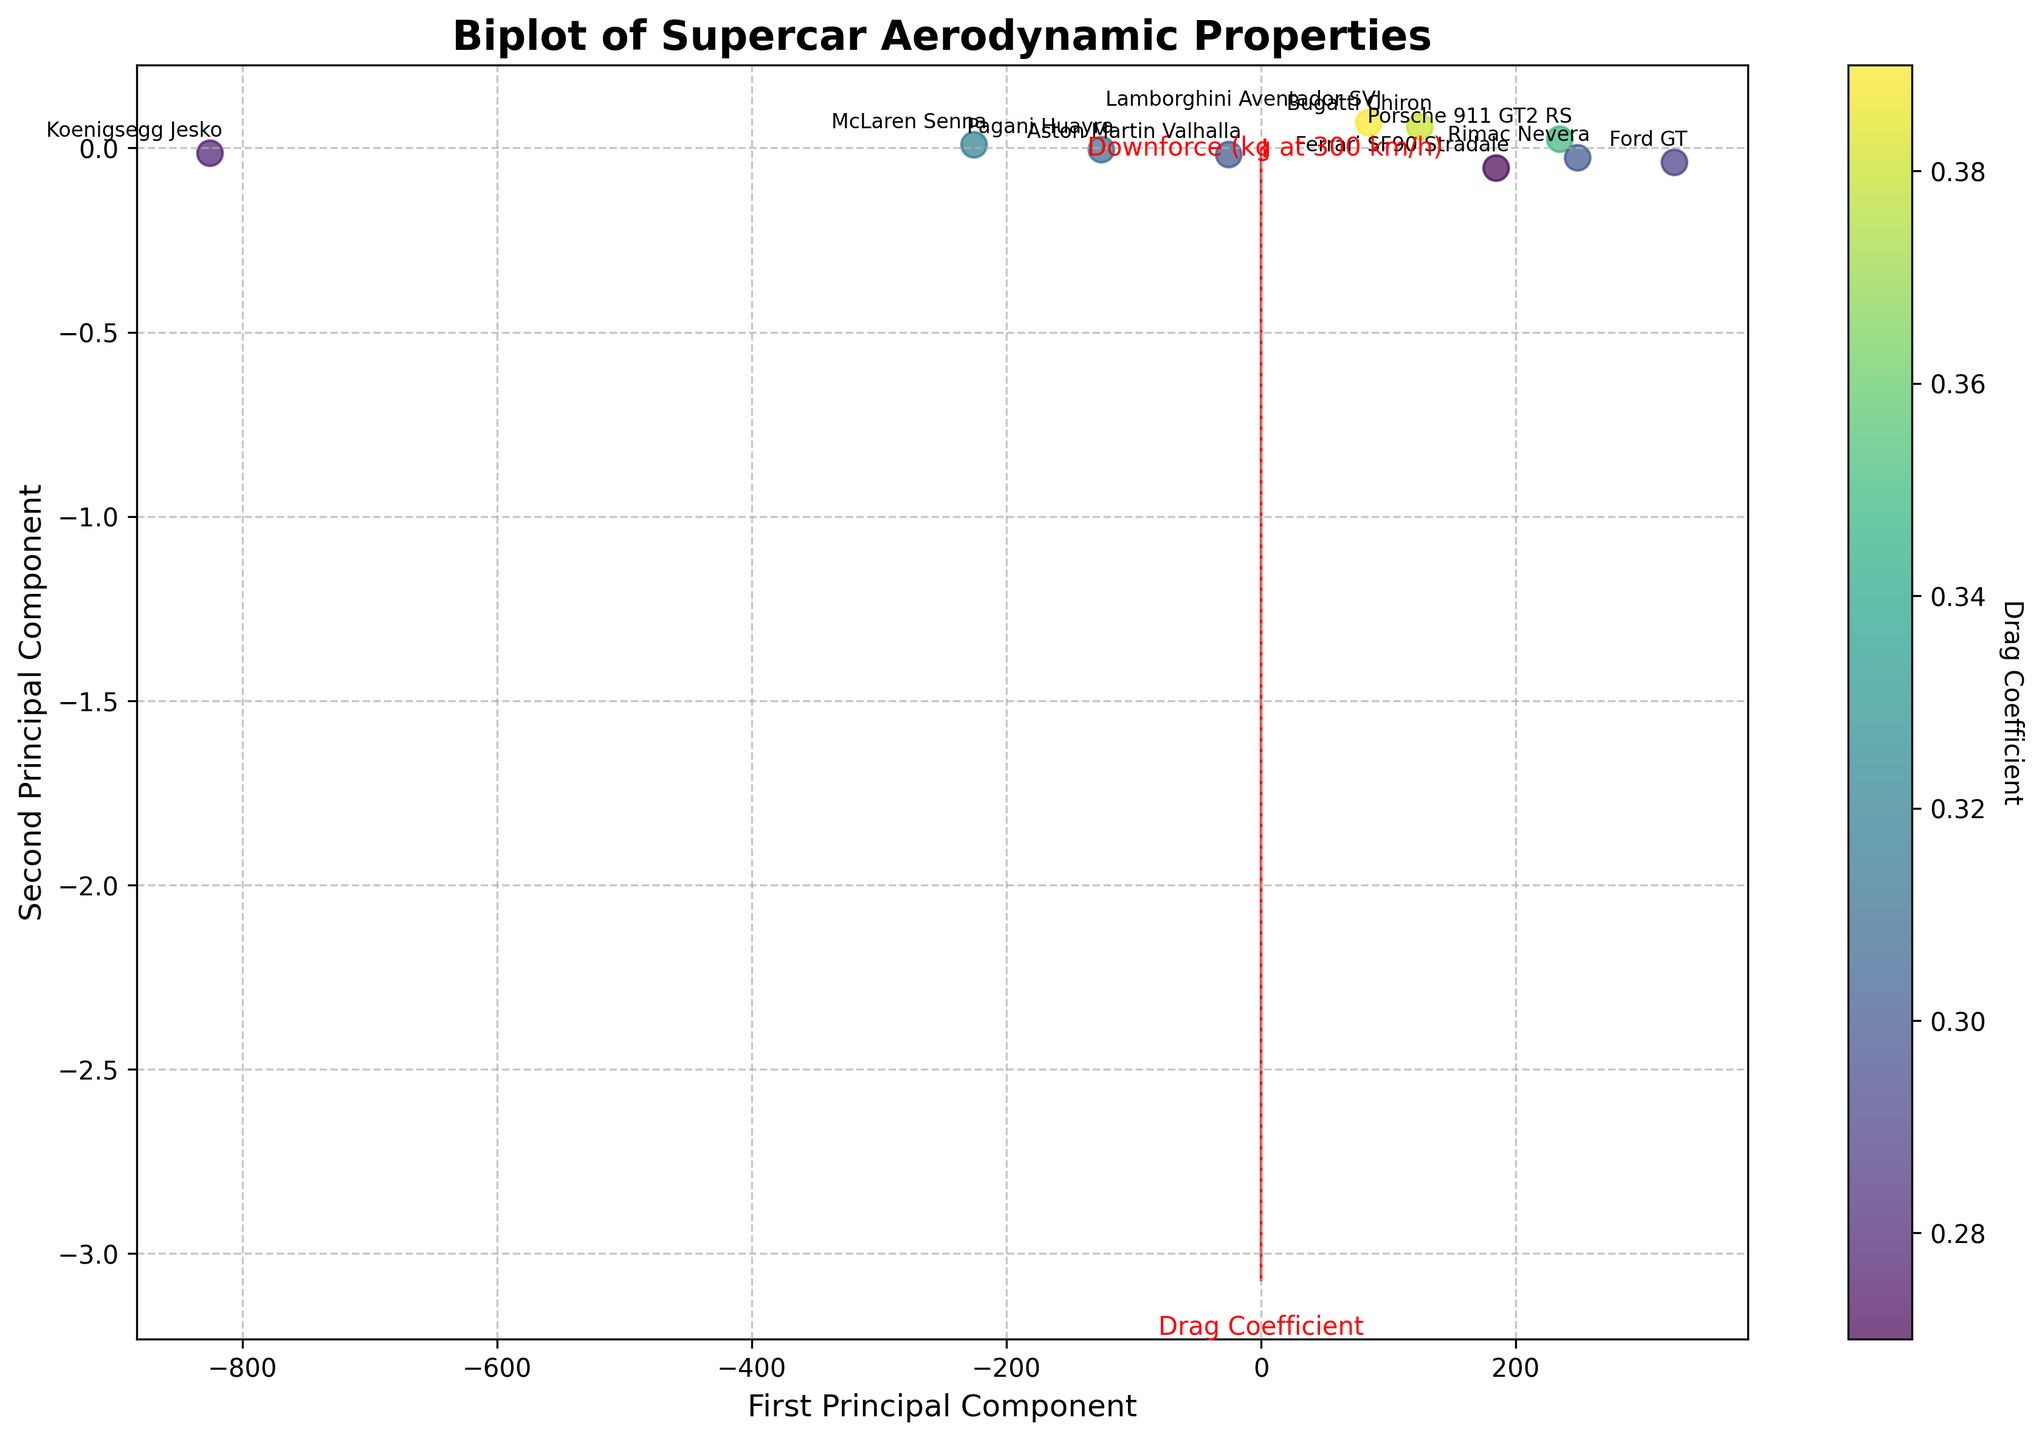What is the title of the plot? The title of the plot is shown prominently at the top of the figure.
Answer: Biplot of Supercar Aerodynamic Properties How many car models are represented in the plot? The car models are indicated by the individual labels on the plot. Count the number of unique labels to get the number of car models.
Answer: 10 Which supercar has the lowest drag coefficient? The colorbar on the right side of the plot indicates the drag coefficient. Look for the point with the darkest color on the colorbar scale.
Answer: Ferrari SF90 Stradale Which supercar has the highest downforce? Downforce is related to the projection on the second principal component, where higher values on the biplot axis indicate higher downforce. Find the point with the highest position in the second principal component.
Answer: Koenigsegg Jesko How are the drag coefficient and downforce related according to the feature vectors? The feature vectors, represented by arrows, show the direction and magnitude of each aerodynamic property. Examine the angles between the arrows to determine the relationships.
Answer: Inversely related Which car model is positioned closest to the center of the plot? The center of the plot represents the mean of the data. Identify the point closest to this position.
Answer: Ford GT Compare the drag coefficient of the Bugatti Chiron and the McLaren Senna. Which is higher? Use the color coding on the points corresponding to the Bugatti Chiron and McLaren Senna and compare their color intensities relative to the colorbar.
Answer: Bugatti Chiron Which car model shows a balance between a low drag coefficient and high downforce? Identify the car model positioned where the projection of both principal components suggests a balance, particularly paying attention to both vector directions.
Answer: Pagani Huayra What is the principal component value for the Ferrari SF90 Stradale on the first principal component axis? Look at the position of the Ferrari SF90 Stradale along the x-axis (first principal component) on the plot.
Answer: Approximately -2 Between the Porsche 911 GT2 RS and Aston Martin Valhalla, which has a higher downforce? Compare the vertical positions of the points for Porsche 911 GT2 RS and Aston Martin Valhalla, as the second principal component represents downforce.
Answer: Aston Martin Valhalla 